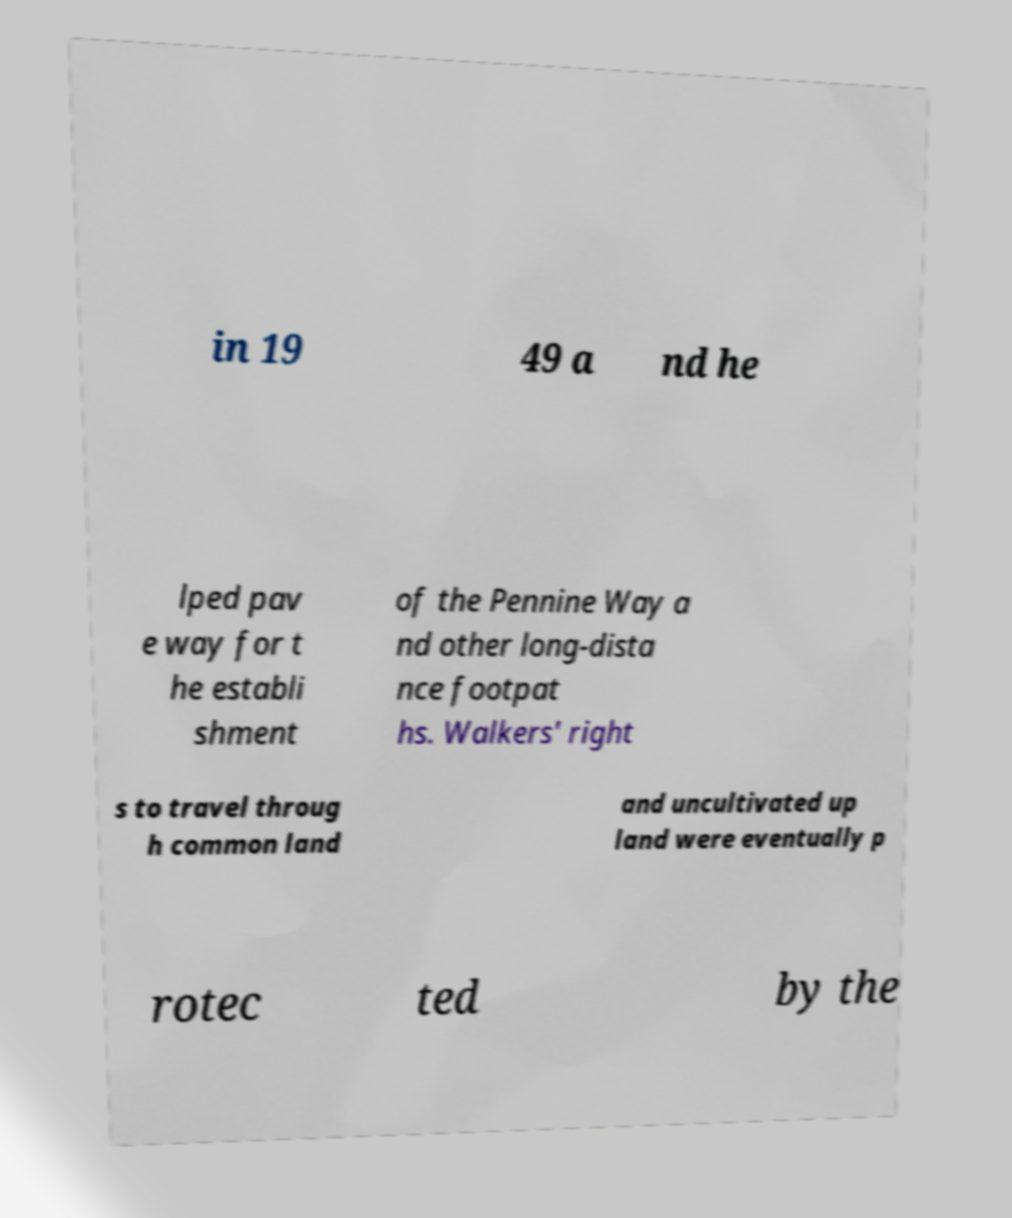Can you read and provide the text displayed in the image?This photo seems to have some interesting text. Can you extract and type it out for me? in 19 49 a nd he lped pav e way for t he establi shment of the Pennine Way a nd other long-dista nce footpat hs. Walkers' right s to travel throug h common land and uncultivated up land were eventually p rotec ted by the 